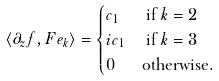Convert formula to latex. <formula><loc_0><loc_0><loc_500><loc_500>\langle \partial _ { z } f , F e _ { k } \rangle & = \begin{cases} c _ { 1 } & \text { if } k = 2 \\ i c _ { 1 } & \text { if } k = 3 \\ 0 & \text {otherwise} . \end{cases}</formula> 